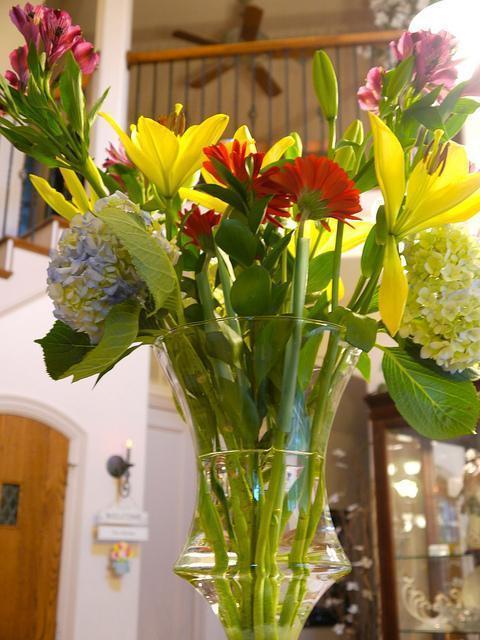How many potted plants are in the photo?
Give a very brief answer. 1. 